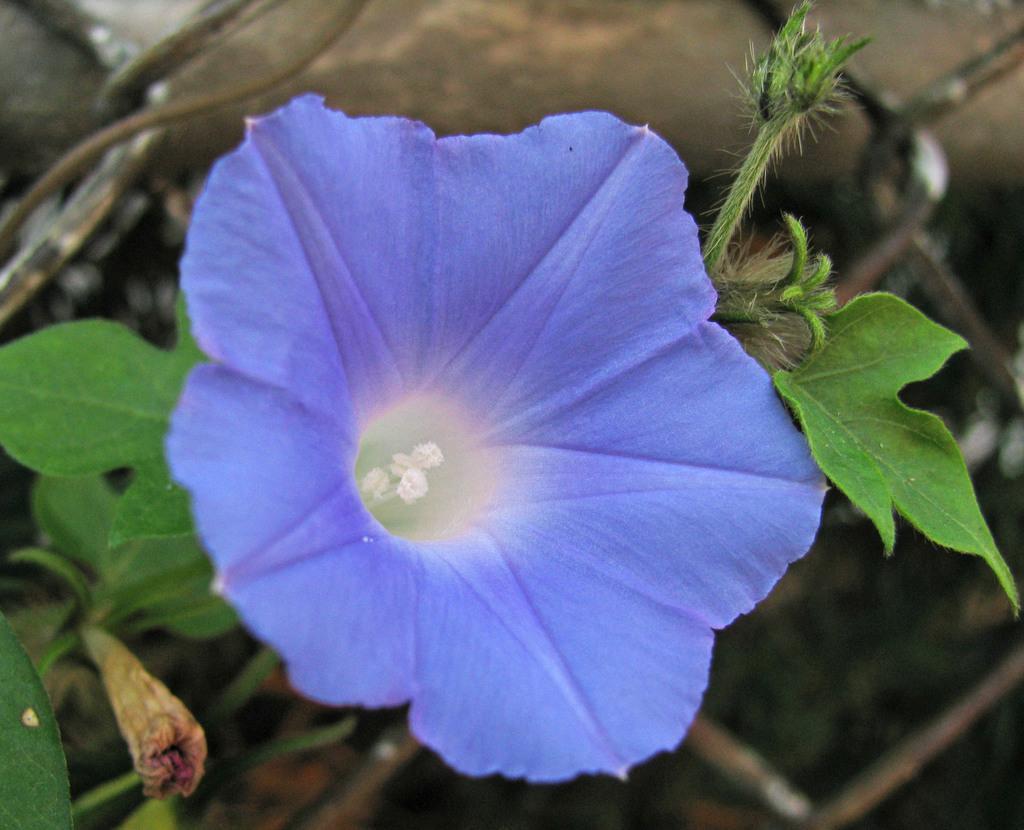Describe this image in one or two sentences. In this image there is a plant with the flower. 